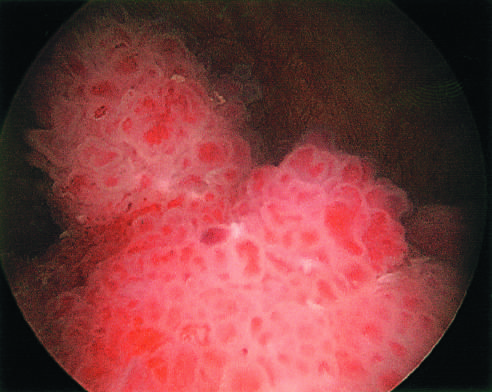did the initial reaction complex within the bladder resemble coral?
Answer the question using a single word or phrase. No 